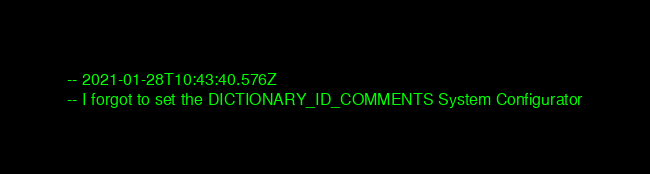Convert code to text. <code><loc_0><loc_0><loc_500><loc_500><_SQL_>-- 2021-01-28T10:43:40.576Z
-- I forgot to set the DICTIONARY_ID_COMMENTS System Configurator</code> 